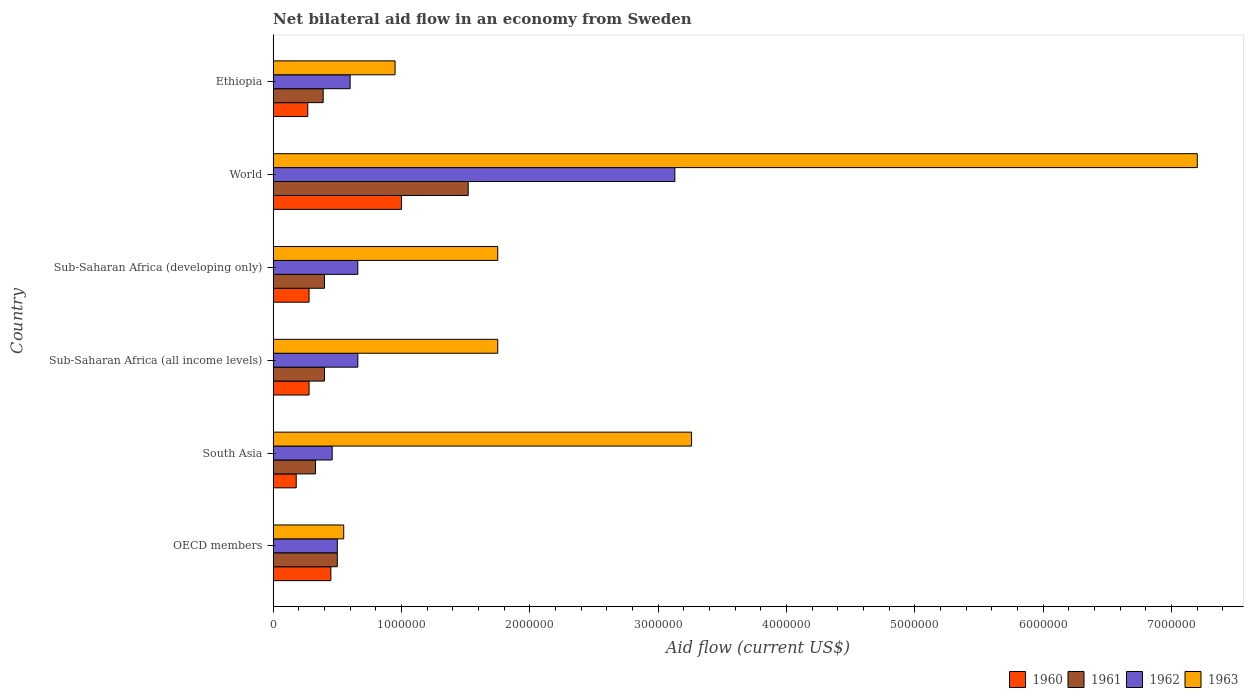What is the label of the 4th group of bars from the top?
Your answer should be very brief. Sub-Saharan Africa (all income levels). In how many cases, is the number of bars for a given country not equal to the number of legend labels?
Keep it short and to the point. 0. What is the net bilateral aid flow in 1961 in Sub-Saharan Africa (all income levels)?
Provide a short and direct response. 4.00e+05. Across all countries, what is the minimum net bilateral aid flow in 1963?
Your answer should be compact. 5.50e+05. What is the total net bilateral aid flow in 1960 in the graph?
Keep it short and to the point. 2.46e+06. What is the difference between the net bilateral aid flow in 1961 in Ethiopia and that in Sub-Saharan Africa (all income levels)?
Offer a very short reply. -10000. What is the difference between the net bilateral aid flow in 1961 and net bilateral aid flow in 1963 in Sub-Saharan Africa (developing only)?
Offer a very short reply. -1.35e+06. In how many countries, is the net bilateral aid flow in 1963 greater than 3400000 US$?
Your answer should be compact. 1. What is the ratio of the net bilateral aid flow in 1962 in Sub-Saharan Africa (developing only) to that in World?
Your answer should be compact. 0.21. Is the net bilateral aid flow in 1962 in Ethiopia less than that in Sub-Saharan Africa (developing only)?
Keep it short and to the point. Yes. Is the difference between the net bilateral aid flow in 1961 in Ethiopia and Sub-Saharan Africa (developing only) greater than the difference between the net bilateral aid flow in 1963 in Ethiopia and Sub-Saharan Africa (developing only)?
Your answer should be compact. Yes. What is the difference between the highest and the second highest net bilateral aid flow in 1961?
Provide a succinct answer. 1.02e+06. What is the difference between the highest and the lowest net bilateral aid flow in 1960?
Keep it short and to the point. 8.20e+05. What does the 2nd bar from the top in Sub-Saharan Africa (developing only) represents?
Provide a succinct answer. 1962. How many bars are there?
Your answer should be compact. 24. Are all the bars in the graph horizontal?
Offer a terse response. Yes. How many countries are there in the graph?
Offer a very short reply. 6. Does the graph contain grids?
Offer a terse response. No. Where does the legend appear in the graph?
Provide a succinct answer. Bottom right. How many legend labels are there?
Provide a succinct answer. 4. What is the title of the graph?
Provide a succinct answer. Net bilateral aid flow in an economy from Sweden. What is the Aid flow (current US$) of 1961 in OECD members?
Ensure brevity in your answer.  5.00e+05. What is the Aid flow (current US$) in 1961 in South Asia?
Provide a short and direct response. 3.30e+05. What is the Aid flow (current US$) of 1963 in South Asia?
Offer a very short reply. 3.26e+06. What is the Aid flow (current US$) in 1961 in Sub-Saharan Africa (all income levels)?
Ensure brevity in your answer.  4.00e+05. What is the Aid flow (current US$) of 1963 in Sub-Saharan Africa (all income levels)?
Your response must be concise. 1.75e+06. What is the Aid flow (current US$) of 1960 in Sub-Saharan Africa (developing only)?
Your answer should be compact. 2.80e+05. What is the Aid flow (current US$) in 1961 in Sub-Saharan Africa (developing only)?
Your answer should be very brief. 4.00e+05. What is the Aid flow (current US$) of 1963 in Sub-Saharan Africa (developing only)?
Your response must be concise. 1.75e+06. What is the Aid flow (current US$) in 1960 in World?
Offer a terse response. 1.00e+06. What is the Aid flow (current US$) in 1961 in World?
Provide a succinct answer. 1.52e+06. What is the Aid flow (current US$) in 1962 in World?
Your answer should be compact. 3.13e+06. What is the Aid flow (current US$) of 1963 in World?
Your response must be concise. 7.20e+06. What is the Aid flow (current US$) in 1962 in Ethiopia?
Your answer should be very brief. 6.00e+05. What is the Aid flow (current US$) in 1963 in Ethiopia?
Your answer should be compact. 9.50e+05. Across all countries, what is the maximum Aid flow (current US$) of 1961?
Keep it short and to the point. 1.52e+06. Across all countries, what is the maximum Aid flow (current US$) of 1962?
Provide a short and direct response. 3.13e+06. Across all countries, what is the maximum Aid flow (current US$) of 1963?
Ensure brevity in your answer.  7.20e+06. Across all countries, what is the minimum Aid flow (current US$) of 1960?
Provide a succinct answer. 1.80e+05. Across all countries, what is the minimum Aid flow (current US$) in 1961?
Keep it short and to the point. 3.30e+05. What is the total Aid flow (current US$) in 1960 in the graph?
Keep it short and to the point. 2.46e+06. What is the total Aid flow (current US$) of 1961 in the graph?
Keep it short and to the point. 3.54e+06. What is the total Aid flow (current US$) of 1962 in the graph?
Your answer should be compact. 6.01e+06. What is the total Aid flow (current US$) in 1963 in the graph?
Provide a short and direct response. 1.55e+07. What is the difference between the Aid flow (current US$) of 1961 in OECD members and that in South Asia?
Give a very brief answer. 1.70e+05. What is the difference between the Aid flow (current US$) in 1962 in OECD members and that in South Asia?
Make the answer very short. 4.00e+04. What is the difference between the Aid flow (current US$) in 1963 in OECD members and that in South Asia?
Provide a succinct answer. -2.71e+06. What is the difference between the Aid flow (current US$) in 1960 in OECD members and that in Sub-Saharan Africa (all income levels)?
Provide a succinct answer. 1.70e+05. What is the difference between the Aid flow (current US$) in 1961 in OECD members and that in Sub-Saharan Africa (all income levels)?
Your response must be concise. 1.00e+05. What is the difference between the Aid flow (current US$) in 1963 in OECD members and that in Sub-Saharan Africa (all income levels)?
Offer a terse response. -1.20e+06. What is the difference between the Aid flow (current US$) of 1961 in OECD members and that in Sub-Saharan Africa (developing only)?
Keep it short and to the point. 1.00e+05. What is the difference between the Aid flow (current US$) of 1963 in OECD members and that in Sub-Saharan Africa (developing only)?
Offer a very short reply. -1.20e+06. What is the difference between the Aid flow (current US$) in 1960 in OECD members and that in World?
Keep it short and to the point. -5.50e+05. What is the difference between the Aid flow (current US$) in 1961 in OECD members and that in World?
Make the answer very short. -1.02e+06. What is the difference between the Aid flow (current US$) in 1962 in OECD members and that in World?
Provide a succinct answer. -2.63e+06. What is the difference between the Aid flow (current US$) of 1963 in OECD members and that in World?
Your answer should be very brief. -6.65e+06. What is the difference between the Aid flow (current US$) in 1963 in OECD members and that in Ethiopia?
Offer a terse response. -4.00e+05. What is the difference between the Aid flow (current US$) in 1961 in South Asia and that in Sub-Saharan Africa (all income levels)?
Your answer should be compact. -7.00e+04. What is the difference between the Aid flow (current US$) in 1962 in South Asia and that in Sub-Saharan Africa (all income levels)?
Ensure brevity in your answer.  -2.00e+05. What is the difference between the Aid flow (current US$) in 1963 in South Asia and that in Sub-Saharan Africa (all income levels)?
Your response must be concise. 1.51e+06. What is the difference between the Aid flow (current US$) in 1962 in South Asia and that in Sub-Saharan Africa (developing only)?
Make the answer very short. -2.00e+05. What is the difference between the Aid flow (current US$) in 1963 in South Asia and that in Sub-Saharan Africa (developing only)?
Provide a succinct answer. 1.51e+06. What is the difference between the Aid flow (current US$) of 1960 in South Asia and that in World?
Offer a very short reply. -8.20e+05. What is the difference between the Aid flow (current US$) in 1961 in South Asia and that in World?
Offer a terse response. -1.19e+06. What is the difference between the Aid flow (current US$) in 1962 in South Asia and that in World?
Your answer should be very brief. -2.67e+06. What is the difference between the Aid flow (current US$) of 1963 in South Asia and that in World?
Your response must be concise. -3.94e+06. What is the difference between the Aid flow (current US$) in 1960 in South Asia and that in Ethiopia?
Your answer should be compact. -9.00e+04. What is the difference between the Aid flow (current US$) in 1961 in South Asia and that in Ethiopia?
Offer a very short reply. -6.00e+04. What is the difference between the Aid flow (current US$) in 1963 in South Asia and that in Ethiopia?
Make the answer very short. 2.31e+06. What is the difference between the Aid flow (current US$) of 1960 in Sub-Saharan Africa (all income levels) and that in Sub-Saharan Africa (developing only)?
Your answer should be compact. 0. What is the difference between the Aid flow (current US$) in 1962 in Sub-Saharan Africa (all income levels) and that in Sub-Saharan Africa (developing only)?
Your answer should be compact. 0. What is the difference between the Aid flow (current US$) of 1963 in Sub-Saharan Africa (all income levels) and that in Sub-Saharan Africa (developing only)?
Ensure brevity in your answer.  0. What is the difference between the Aid flow (current US$) in 1960 in Sub-Saharan Africa (all income levels) and that in World?
Offer a very short reply. -7.20e+05. What is the difference between the Aid flow (current US$) of 1961 in Sub-Saharan Africa (all income levels) and that in World?
Your answer should be very brief. -1.12e+06. What is the difference between the Aid flow (current US$) in 1962 in Sub-Saharan Africa (all income levels) and that in World?
Provide a short and direct response. -2.47e+06. What is the difference between the Aid flow (current US$) in 1963 in Sub-Saharan Africa (all income levels) and that in World?
Give a very brief answer. -5.45e+06. What is the difference between the Aid flow (current US$) of 1962 in Sub-Saharan Africa (all income levels) and that in Ethiopia?
Make the answer very short. 6.00e+04. What is the difference between the Aid flow (current US$) of 1960 in Sub-Saharan Africa (developing only) and that in World?
Provide a short and direct response. -7.20e+05. What is the difference between the Aid flow (current US$) in 1961 in Sub-Saharan Africa (developing only) and that in World?
Give a very brief answer. -1.12e+06. What is the difference between the Aid flow (current US$) of 1962 in Sub-Saharan Africa (developing only) and that in World?
Offer a terse response. -2.47e+06. What is the difference between the Aid flow (current US$) in 1963 in Sub-Saharan Africa (developing only) and that in World?
Provide a succinct answer. -5.45e+06. What is the difference between the Aid flow (current US$) in 1963 in Sub-Saharan Africa (developing only) and that in Ethiopia?
Ensure brevity in your answer.  8.00e+05. What is the difference between the Aid flow (current US$) in 1960 in World and that in Ethiopia?
Make the answer very short. 7.30e+05. What is the difference between the Aid flow (current US$) in 1961 in World and that in Ethiopia?
Your answer should be compact. 1.13e+06. What is the difference between the Aid flow (current US$) of 1962 in World and that in Ethiopia?
Offer a very short reply. 2.53e+06. What is the difference between the Aid flow (current US$) of 1963 in World and that in Ethiopia?
Offer a very short reply. 6.25e+06. What is the difference between the Aid flow (current US$) in 1960 in OECD members and the Aid flow (current US$) in 1962 in South Asia?
Provide a short and direct response. -10000. What is the difference between the Aid flow (current US$) in 1960 in OECD members and the Aid flow (current US$) in 1963 in South Asia?
Your answer should be very brief. -2.81e+06. What is the difference between the Aid flow (current US$) in 1961 in OECD members and the Aid flow (current US$) in 1962 in South Asia?
Ensure brevity in your answer.  4.00e+04. What is the difference between the Aid flow (current US$) of 1961 in OECD members and the Aid flow (current US$) of 1963 in South Asia?
Provide a succinct answer. -2.76e+06. What is the difference between the Aid flow (current US$) of 1962 in OECD members and the Aid flow (current US$) of 1963 in South Asia?
Provide a short and direct response. -2.76e+06. What is the difference between the Aid flow (current US$) of 1960 in OECD members and the Aid flow (current US$) of 1961 in Sub-Saharan Africa (all income levels)?
Your answer should be very brief. 5.00e+04. What is the difference between the Aid flow (current US$) in 1960 in OECD members and the Aid flow (current US$) in 1962 in Sub-Saharan Africa (all income levels)?
Your answer should be very brief. -2.10e+05. What is the difference between the Aid flow (current US$) in 1960 in OECD members and the Aid flow (current US$) in 1963 in Sub-Saharan Africa (all income levels)?
Make the answer very short. -1.30e+06. What is the difference between the Aid flow (current US$) of 1961 in OECD members and the Aid flow (current US$) of 1962 in Sub-Saharan Africa (all income levels)?
Offer a very short reply. -1.60e+05. What is the difference between the Aid flow (current US$) in 1961 in OECD members and the Aid flow (current US$) in 1963 in Sub-Saharan Africa (all income levels)?
Your response must be concise. -1.25e+06. What is the difference between the Aid flow (current US$) of 1962 in OECD members and the Aid flow (current US$) of 1963 in Sub-Saharan Africa (all income levels)?
Ensure brevity in your answer.  -1.25e+06. What is the difference between the Aid flow (current US$) of 1960 in OECD members and the Aid flow (current US$) of 1962 in Sub-Saharan Africa (developing only)?
Keep it short and to the point. -2.10e+05. What is the difference between the Aid flow (current US$) in 1960 in OECD members and the Aid flow (current US$) in 1963 in Sub-Saharan Africa (developing only)?
Make the answer very short. -1.30e+06. What is the difference between the Aid flow (current US$) of 1961 in OECD members and the Aid flow (current US$) of 1962 in Sub-Saharan Africa (developing only)?
Make the answer very short. -1.60e+05. What is the difference between the Aid flow (current US$) in 1961 in OECD members and the Aid flow (current US$) in 1963 in Sub-Saharan Africa (developing only)?
Provide a succinct answer. -1.25e+06. What is the difference between the Aid flow (current US$) of 1962 in OECD members and the Aid flow (current US$) of 1963 in Sub-Saharan Africa (developing only)?
Ensure brevity in your answer.  -1.25e+06. What is the difference between the Aid flow (current US$) of 1960 in OECD members and the Aid flow (current US$) of 1961 in World?
Your response must be concise. -1.07e+06. What is the difference between the Aid flow (current US$) in 1960 in OECD members and the Aid flow (current US$) in 1962 in World?
Make the answer very short. -2.68e+06. What is the difference between the Aid flow (current US$) in 1960 in OECD members and the Aid flow (current US$) in 1963 in World?
Make the answer very short. -6.75e+06. What is the difference between the Aid flow (current US$) of 1961 in OECD members and the Aid flow (current US$) of 1962 in World?
Make the answer very short. -2.63e+06. What is the difference between the Aid flow (current US$) in 1961 in OECD members and the Aid flow (current US$) in 1963 in World?
Your answer should be compact. -6.70e+06. What is the difference between the Aid flow (current US$) of 1962 in OECD members and the Aid flow (current US$) of 1963 in World?
Make the answer very short. -6.70e+06. What is the difference between the Aid flow (current US$) of 1960 in OECD members and the Aid flow (current US$) of 1962 in Ethiopia?
Your answer should be very brief. -1.50e+05. What is the difference between the Aid flow (current US$) of 1960 in OECD members and the Aid flow (current US$) of 1963 in Ethiopia?
Ensure brevity in your answer.  -5.00e+05. What is the difference between the Aid flow (current US$) of 1961 in OECD members and the Aid flow (current US$) of 1963 in Ethiopia?
Offer a terse response. -4.50e+05. What is the difference between the Aid flow (current US$) of 1962 in OECD members and the Aid flow (current US$) of 1963 in Ethiopia?
Keep it short and to the point. -4.50e+05. What is the difference between the Aid flow (current US$) in 1960 in South Asia and the Aid flow (current US$) in 1961 in Sub-Saharan Africa (all income levels)?
Make the answer very short. -2.20e+05. What is the difference between the Aid flow (current US$) in 1960 in South Asia and the Aid flow (current US$) in 1962 in Sub-Saharan Africa (all income levels)?
Offer a terse response. -4.80e+05. What is the difference between the Aid flow (current US$) in 1960 in South Asia and the Aid flow (current US$) in 1963 in Sub-Saharan Africa (all income levels)?
Offer a terse response. -1.57e+06. What is the difference between the Aid flow (current US$) of 1961 in South Asia and the Aid flow (current US$) of 1962 in Sub-Saharan Africa (all income levels)?
Your answer should be very brief. -3.30e+05. What is the difference between the Aid flow (current US$) of 1961 in South Asia and the Aid flow (current US$) of 1963 in Sub-Saharan Africa (all income levels)?
Ensure brevity in your answer.  -1.42e+06. What is the difference between the Aid flow (current US$) of 1962 in South Asia and the Aid flow (current US$) of 1963 in Sub-Saharan Africa (all income levels)?
Offer a very short reply. -1.29e+06. What is the difference between the Aid flow (current US$) in 1960 in South Asia and the Aid flow (current US$) in 1961 in Sub-Saharan Africa (developing only)?
Provide a succinct answer. -2.20e+05. What is the difference between the Aid flow (current US$) in 1960 in South Asia and the Aid flow (current US$) in 1962 in Sub-Saharan Africa (developing only)?
Your response must be concise. -4.80e+05. What is the difference between the Aid flow (current US$) of 1960 in South Asia and the Aid flow (current US$) of 1963 in Sub-Saharan Africa (developing only)?
Provide a succinct answer. -1.57e+06. What is the difference between the Aid flow (current US$) of 1961 in South Asia and the Aid flow (current US$) of 1962 in Sub-Saharan Africa (developing only)?
Offer a very short reply. -3.30e+05. What is the difference between the Aid flow (current US$) in 1961 in South Asia and the Aid flow (current US$) in 1963 in Sub-Saharan Africa (developing only)?
Your answer should be compact. -1.42e+06. What is the difference between the Aid flow (current US$) of 1962 in South Asia and the Aid flow (current US$) of 1963 in Sub-Saharan Africa (developing only)?
Offer a very short reply. -1.29e+06. What is the difference between the Aid flow (current US$) of 1960 in South Asia and the Aid flow (current US$) of 1961 in World?
Your answer should be compact. -1.34e+06. What is the difference between the Aid flow (current US$) of 1960 in South Asia and the Aid flow (current US$) of 1962 in World?
Give a very brief answer. -2.95e+06. What is the difference between the Aid flow (current US$) in 1960 in South Asia and the Aid flow (current US$) in 1963 in World?
Your answer should be very brief. -7.02e+06. What is the difference between the Aid flow (current US$) in 1961 in South Asia and the Aid flow (current US$) in 1962 in World?
Provide a short and direct response. -2.80e+06. What is the difference between the Aid flow (current US$) of 1961 in South Asia and the Aid flow (current US$) of 1963 in World?
Your answer should be very brief. -6.87e+06. What is the difference between the Aid flow (current US$) in 1962 in South Asia and the Aid flow (current US$) in 1963 in World?
Your answer should be very brief. -6.74e+06. What is the difference between the Aid flow (current US$) of 1960 in South Asia and the Aid flow (current US$) of 1961 in Ethiopia?
Give a very brief answer. -2.10e+05. What is the difference between the Aid flow (current US$) in 1960 in South Asia and the Aid flow (current US$) in 1962 in Ethiopia?
Make the answer very short. -4.20e+05. What is the difference between the Aid flow (current US$) in 1960 in South Asia and the Aid flow (current US$) in 1963 in Ethiopia?
Your answer should be very brief. -7.70e+05. What is the difference between the Aid flow (current US$) in 1961 in South Asia and the Aid flow (current US$) in 1963 in Ethiopia?
Your response must be concise. -6.20e+05. What is the difference between the Aid flow (current US$) of 1962 in South Asia and the Aid flow (current US$) of 1963 in Ethiopia?
Ensure brevity in your answer.  -4.90e+05. What is the difference between the Aid flow (current US$) in 1960 in Sub-Saharan Africa (all income levels) and the Aid flow (current US$) in 1961 in Sub-Saharan Africa (developing only)?
Your response must be concise. -1.20e+05. What is the difference between the Aid flow (current US$) in 1960 in Sub-Saharan Africa (all income levels) and the Aid flow (current US$) in 1962 in Sub-Saharan Africa (developing only)?
Give a very brief answer. -3.80e+05. What is the difference between the Aid flow (current US$) in 1960 in Sub-Saharan Africa (all income levels) and the Aid flow (current US$) in 1963 in Sub-Saharan Africa (developing only)?
Provide a short and direct response. -1.47e+06. What is the difference between the Aid flow (current US$) in 1961 in Sub-Saharan Africa (all income levels) and the Aid flow (current US$) in 1962 in Sub-Saharan Africa (developing only)?
Provide a short and direct response. -2.60e+05. What is the difference between the Aid flow (current US$) in 1961 in Sub-Saharan Africa (all income levels) and the Aid flow (current US$) in 1963 in Sub-Saharan Africa (developing only)?
Ensure brevity in your answer.  -1.35e+06. What is the difference between the Aid flow (current US$) in 1962 in Sub-Saharan Africa (all income levels) and the Aid flow (current US$) in 1963 in Sub-Saharan Africa (developing only)?
Keep it short and to the point. -1.09e+06. What is the difference between the Aid flow (current US$) in 1960 in Sub-Saharan Africa (all income levels) and the Aid flow (current US$) in 1961 in World?
Your response must be concise. -1.24e+06. What is the difference between the Aid flow (current US$) in 1960 in Sub-Saharan Africa (all income levels) and the Aid flow (current US$) in 1962 in World?
Ensure brevity in your answer.  -2.85e+06. What is the difference between the Aid flow (current US$) in 1960 in Sub-Saharan Africa (all income levels) and the Aid flow (current US$) in 1963 in World?
Your response must be concise. -6.92e+06. What is the difference between the Aid flow (current US$) of 1961 in Sub-Saharan Africa (all income levels) and the Aid flow (current US$) of 1962 in World?
Provide a succinct answer. -2.73e+06. What is the difference between the Aid flow (current US$) in 1961 in Sub-Saharan Africa (all income levels) and the Aid flow (current US$) in 1963 in World?
Your answer should be compact. -6.80e+06. What is the difference between the Aid flow (current US$) of 1962 in Sub-Saharan Africa (all income levels) and the Aid flow (current US$) of 1963 in World?
Give a very brief answer. -6.54e+06. What is the difference between the Aid flow (current US$) in 1960 in Sub-Saharan Africa (all income levels) and the Aid flow (current US$) in 1962 in Ethiopia?
Offer a very short reply. -3.20e+05. What is the difference between the Aid flow (current US$) in 1960 in Sub-Saharan Africa (all income levels) and the Aid flow (current US$) in 1963 in Ethiopia?
Your response must be concise. -6.70e+05. What is the difference between the Aid flow (current US$) in 1961 in Sub-Saharan Africa (all income levels) and the Aid flow (current US$) in 1962 in Ethiopia?
Your answer should be very brief. -2.00e+05. What is the difference between the Aid flow (current US$) of 1961 in Sub-Saharan Africa (all income levels) and the Aid flow (current US$) of 1963 in Ethiopia?
Keep it short and to the point. -5.50e+05. What is the difference between the Aid flow (current US$) of 1962 in Sub-Saharan Africa (all income levels) and the Aid flow (current US$) of 1963 in Ethiopia?
Give a very brief answer. -2.90e+05. What is the difference between the Aid flow (current US$) in 1960 in Sub-Saharan Africa (developing only) and the Aid flow (current US$) in 1961 in World?
Keep it short and to the point. -1.24e+06. What is the difference between the Aid flow (current US$) of 1960 in Sub-Saharan Africa (developing only) and the Aid flow (current US$) of 1962 in World?
Keep it short and to the point. -2.85e+06. What is the difference between the Aid flow (current US$) of 1960 in Sub-Saharan Africa (developing only) and the Aid flow (current US$) of 1963 in World?
Your answer should be very brief. -6.92e+06. What is the difference between the Aid flow (current US$) in 1961 in Sub-Saharan Africa (developing only) and the Aid flow (current US$) in 1962 in World?
Make the answer very short. -2.73e+06. What is the difference between the Aid flow (current US$) of 1961 in Sub-Saharan Africa (developing only) and the Aid flow (current US$) of 1963 in World?
Provide a succinct answer. -6.80e+06. What is the difference between the Aid flow (current US$) in 1962 in Sub-Saharan Africa (developing only) and the Aid flow (current US$) in 1963 in World?
Provide a succinct answer. -6.54e+06. What is the difference between the Aid flow (current US$) of 1960 in Sub-Saharan Africa (developing only) and the Aid flow (current US$) of 1962 in Ethiopia?
Provide a short and direct response. -3.20e+05. What is the difference between the Aid flow (current US$) of 1960 in Sub-Saharan Africa (developing only) and the Aid flow (current US$) of 1963 in Ethiopia?
Provide a short and direct response. -6.70e+05. What is the difference between the Aid flow (current US$) of 1961 in Sub-Saharan Africa (developing only) and the Aid flow (current US$) of 1963 in Ethiopia?
Keep it short and to the point. -5.50e+05. What is the difference between the Aid flow (current US$) of 1962 in Sub-Saharan Africa (developing only) and the Aid flow (current US$) of 1963 in Ethiopia?
Offer a very short reply. -2.90e+05. What is the difference between the Aid flow (current US$) of 1960 in World and the Aid flow (current US$) of 1962 in Ethiopia?
Give a very brief answer. 4.00e+05. What is the difference between the Aid flow (current US$) in 1961 in World and the Aid flow (current US$) in 1962 in Ethiopia?
Offer a very short reply. 9.20e+05. What is the difference between the Aid flow (current US$) in 1961 in World and the Aid flow (current US$) in 1963 in Ethiopia?
Offer a very short reply. 5.70e+05. What is the difference between the Aid flow (current US$) in 1962 in World and the Aid flow (current US$) in 1963 in Ethiopia?
Your answer should be very brief. 2.18e+06. What is the average Aid flow (current US$) in 1961 per country?
Ensure brevity in your answer.  5.90e+05. What is the average Aid flow (current US$) of 1962 per country?
Keep it short and to the point. 1.00e+06. What is the average Aid flow (current US$) of 1963 per country?
Give a very brief answer. 2.58e+06. What is the difference between the Aid flow (current US$) in 1960 and Aid flow (current US$) in 1961 in OECD members?
Your answer should be compact. -5.00e+04. What is the difference between the Aid flow (current US$) of 1960 and Aid flow (current US$) of 1963 in OECD members?
Offer a very short reply. -1.00e+05. What is the difference between the Aid flow (current US$) of 1961 and Aid flow (current US$) of 1962 in OECD members?
Give a very brief answer. 0. What is the difference between the Aid flow (current US$) in 1961 and Aid flow (current US$) in 1963 in OECD members?
Keep it short and to the point. -5.00e+04. What is the difference between the Aid flow (current US$) in 1962 and Aid flow (current US$) in 1963 in OECD members?
Your answer should be very brief. -5.00e+04. What is the difference between the Aid flow (current US$) in 1960 and Aid flow (current US$) in 1962 in South Asia?
Offer a very short reply. -2.80e+05. What is the difference between the Aid flow (current US$) of 1960 and Aid flow (current US$) of 1963 in South Asia?
Your answer should be very brief. -3.08e+06. What is the difference between the Aid flow (current US$) of 1961 and Aid flow (current US$) of 1962 in South Asia?
Offer a terse response. -1.30e+05. What is the difference between the Aid flow (current US$) of 1961 and Aid flow (current US$) of 1963 in South Asia?
Your answer should be very brief. -2.93e+06. What is the difference between the Aid flow (current US$) in 1962 and Aid flow (current US$) in 1963 in South Asia?
Keep it short and to the point. -2.80e+06. What is the difference between the Aid flow (current US$) in 1960 and Aid flow (current US$) in 1962 in Sub-Saharan Africa (all income levels)?
Your response must be concise. -3.80e+05. What is the difference between the Aid flow (current US$) of 1960 and Aid flow (current US$) of 1963 in Sub-Saharan Africa (all income levels)?
Offer a very short reply. -1.47e+06. What is the difference between the Aid flow (current US$) of 1961 and Aid flow (current US$) of 1962 in Sub-Saharan Africa (all income levels)?
Give a very brief answer. -2.60e+05. What is the difference between the Aid flow (current US$) of 1961 and Aid flow (current US$) of 1963 in Sub-Saharan Africa (all income levels)?
Keep it short and to the point. -1.35e+06. What is the difference between the Aid flow (current US$) in 1962 and Aid flow (current US$) in 1963 in Sub-Saharan Africa (all income levels)?
Provide a short and direct response. -1.09e+06. What is the difference between the Aid flow (current US$) in 1960 and Aid flow (current US$) in 1961 in Sub-Saharan Africa (developing only)?
Your answer should be compact. -1.20e+05. What is the difference between the Aid flow (current US$) in 1960 and Aid flow (current US$) in 1962 in Sub-Saharan Africa (developing only)?
Your answer should be very brief. -3.80e+05. What is the difference between the Aid flow (current US$) of 1960 and Aid flow (current US$) of 1963 in Sub-Saharan Africa (developing only)?
Make the answer very short. -1.47e+06. What is the difference between the Aid flow (current US$) in 1961 and Aid flow (current US$) in 1963 in Sub-Saharan Africa (developing only)?
Keep it short and to the point. -1.35e+06. What is the difference between the Aid flow (current US$) of 1962 and Aid flow (current US$) of 1963 in Sub-Saharan Africa (developing only)?
Provide a succinct answer. -1.09e+06. What is the difference between the Aid flow (current US$) of 1960 and Aid flow (current US$) of 1961 in World?
Provide a succinct answer. -5.20e+05. What is the difference between the Aid flow (current US$) in 1960 and Aid flow (current US$) in 1962 in World?
Provide a succinct answer. -2.13e+06. What is the difference between the Aid flow (current US$) of 1960 and Aid flow (current US$) of 1963 in World?
Your answer should be compact. -6.20e+06. What is the difference between the Aid flow (current US$) in 1961 and Aid flow (current US$) in 1962 in World?
Your response must be concise. -1.61e+06. What is the difference between the Aid flow (current US$) of 1961 and Aid flow (current US$) of 1963 in World?
Your answer should be compact. -5.68e+06. What is the difference between the Aid flow (current US$) of 1962 and Aid flow (current US$) of 1963 in World?
Offer a very short reply. -4.07e+06. What is the difference between the Aid flow (current US$) in 1960 and Aid flow (current US$) in 1962 in Ethiopia?
Offer a terse response. -3.30e+05. What is the difference between the Aid flow (current US$) of 1960 and Aid flow (current US$) of 1963 in Ethiopia?
Provide a succinct answer. -6.80e+05. What is the difference between the Aid flow (current US$) in 1961 and Aid flow (current US$) in 1962 in Ethiopia?
Your answer should be very brief. -2.10e+05. What is the difference between the Aid flow (current US$) in 1961 and Aid flow (current US$) in 1963 in Ethiopia?
Ensure brevity in your answer.  -5.60e+05. What is the difference between the Aid flow (current US$) of 1962 and Aid flow (current US$) of 1963 in Ethiopia?
Offer a very short reply. -3.50e+05. What is the ratio of the Aid flow (current US$) in 1960 in OECD members to that in South Asia?
Make the answer very short. 2.5. What is the ratio of the Aid flow (current US$) of 1961 in OECD members to that in South Asia?
Provide a short and direct response. 1.52. What is the ratio of the Aid flow (current US$) of 1962 in OECD members to that in South Asia?
Provide a short and direct response. 1.09. What is the ratio of the Aid flow (current US$) in 1963 in OECD members to that in South Asia?
Provide a short and direct response. 0.17. What is the ratio of the Aid flow (current US$) of 1960 in OECD members to that in Sub-Saharan Africa (all income levels)?
Your response must be concise. 1.61. What is the ratio of the Aid flow (current US$) in 1961 in OECD members to that in Sub-Saharan Africa (all income levels)?
Ensure brevity in your answer.  1.25. What is the ratio of the Aid flow (current US$) of 1962 in OECD members to that in Sub-Saharan Africa (all income levels)?
Offer a very short reply. 0.76. What is the ratio of the Aid flow (current US$) in 1963 in OECD members to that in Sub-Saharan Africa (all income levels)?
Your answer should be very brief. 0.31. What is the ratio of the Aid flow (current US$) in 1960 in OECD members to that in Sub-Saharan Africa (developing only)?
Your answer should be compact. 1.61. What is the ratio of the Aid flow (current US$) of 1962 in OECD members to that in Sub-Saharan Africa (developing only)?
Provide a succinct answer. 0.76. What is the ratio of the Aid flow (current US$) in 1963 in OECD members to that in Sub-Saharan Africa (developing only)?
Provide a succinct answer. 0.31. What is the ratio of the Aid flow (current US$) of 1960 in OECD members to that in World?
Keep it short and to the point. 0.45. What is the ratio of the Aid flow (current US$) of 1961 in OECD members to that in World?
Offer a terse response. 0.33. What is the ratio of the Aid flow (current US$) of 1962 in OECD members to that in World?
Your answer should be very brief. 0.16. What is the ratio of the Aid flow (current US$) of 1963 in OECD members to that in World?
Offer a very short reply. 0.08. What is the ratio of the Aid flow (current US$) of 1960 in OECD members to that in Ethiopia?
Provide a succinct answer. 1.67. What is the ratio of the Aid flow (current US$) of 1961 in OECD members to that in Ethiopia?
Provide a short and direct response. 1.28. What is the ratio of the Aid flow (current US$) of 1962 in OECD members to that in Ethiopia?
Provide a succinct answer. 0.83. What is the ratio of the Aid flow (current US$) of 1963 in OECD members to that in Ethiopia?
Your response must be concise. 0.58. What is the ratio of the Aid flow (current US$) of 1960 in South Asia to that in Sub-Saharan Africa (all income levels)?
Your response must be concise. 0.64. What is the ratio of the Aid flow (current US$) of 1961 in South Asia to that in Sub-Saharan Africa (all income levels)?
Offer a terse response. 0.82. What is the ratio of the Aid flow (current US$) in 1962 in South Asia to that in Sub-Saharan Africa (all income levels)?
Your response must be concise. 0.7. What is the ratio of the Aid flow (current US$) in 1963 in South Asia to that in Sub-Saharan Africa (all income levels)?
Offer a very short reply. 1.86. What is the ratio of the Aid flow (current US$) in 1960 in South Asia to that in Sub-Saharan Africa (developing only)?
Offer a terse response. 0.64. What is the ratio of the Aid flow (current US$) of 1961 in South Asia to that in Sub-Saharan Africa (developing only)?
Provide a succinct answer. 0.82. What is the ratio of the Aid flow (current US$) of 1962 in South Asia to that in Sub-Saharan Africa (developing only)?
Ensure brevity in your answer.  0.7. What is the ratio of the Aid flow (current US$) in 1963 in South Asia to that in Sub-Saharan Africa (developing only)?
Keep it short and to the point. 1.86. What is the ratio of the Aid flow (current US$) in 1960 in South Asia to that in World?
Make the answer very short. 0.18. What is the ratio of the Aid flow (current US$) of 1961 in South Asia to that in World?
Ensure brevity in your answer.  0.22. What is the ratio of the Aid flow (current US$) in 1962 in South Asia to that in World?
Make the answer very short. 0.15. What is the ratio of the Aid flow (current US$) in 1963 in South Asia to that in World?
Give a very brief answer. 0.45. What is the ratio of the Aid flow (current US$) in 1960 in South Asia to that in Ethiopia?
Offer a very short reply. 0.67. What is the ratio of the Aid flow (current US$) of 1961 in South Asia to that in Ethiopia?
Give a very brief answer. 0.85. What is the ratio of the Aid flow (current US$) in 1962 in South Asia to that in Ethiopia?
Offer a terse response. 0.77. What is the ratio of the Aid flow (current US$) in 1963 in South Asia to that in Ethiopia?
Your answer should be very brief. 3.43. What is the ratio of the Aid flow (current US$) in 1962 in Sub-Saharan Africa (all income levels) to that in Sub-Saharan Africa (developing only)?
Give a very brief answer. 1. What is the ratio of the Aid flow (current US$) of 1963 in Sub-Saharan Africa (all income levels) to that in Sub-Saharan Africa (developing only)?
Give a very brief answer. 1. What is the ratio of the Aid flow (current US$) in 1960 in Sub-Saharan Africa (all income levels) to that in World?
Provide a short and direct response. 0.28. What is the ratio of the Aid flow (current US$) in 1961 in Sub-Saharan Africa (all income levels) to that in World?
Your answer should be compact. 0.26. What is the ratio of the Aid flow (current US$) in 1962 in Sub-Saharan Africa (all income levels) to that in World?
Provide a short and direct response. 0.21. What is the ratio of the Aid flow (current US$) in 1963 in Sub-Saharan Africa (all income levels) to that in World?
Provide a succinct answer. 0.24. What is the ratio of the Aid flow (current US$) of 1961 in Sub-Saharan Africa (all income levels) to that in Ethiopia?
Give a very brief answer. 1.03. What is the ratio of the Aid flow (current US$) of 1963 in Sub-Saharan Africa (all income levels) to that in Ethiopia?
Your answer should be very brief. 1.84. What is the ratio of the Aid flow (current US$) of 1960 in Sub-Saharan Africa (developing only) to that in World?
Provide a short and direct response. 0.28. What is the ratio of the Aid flow (current US$) of 1961 in Sub-Saharan Africa (developing only) to that in World?
Your answer should be compact. 0.26. What is the ratio of the Aid flow (current US$) of 1962 in Sub-Saharan Africa (developing only) to that in World?
Ensure brevity in your answer.  0.21. What is the ratio of the Aid flow (current US$) in 1963 in Sub-Saharan Africa (developing only) to that in World?
Offer a very short reply. 0.24. What is the ratio of the Aid flow (current US$) of 1960 in Sub-Saharan Africa (developing only) to that in Ethiopia?
Ensure brevity in your answer.  1.04. What is the ratio of the Aid flow (current US$) in 1961 in Sub-Saharan Africa (developing only) to that in Ethiopia?
Your answer should be very brief. 1.03. What is the ratio of the Aid flow (current US$) of 1962 in Sub-Saharan Africa (developing only) to that in Ethiopia?
Ensure brevity in your answer.  1.1. What is the ratio of the Aid flow (current US$) in 1963 in Sub-Saharan Africa (developing only) to that in Ethiopia?
Your answer should be compact. 1.84. What is the ratio of the Aid flow (current US$) in 1960 in World to that in Ethiopia?
Ensure brevity in your answer.  3.7. What is the ratio of the Aid flow (current US$) of 1961 in World to that in Ethiopia?
Your answer should be very brief. 3.9. What is the ratio of the Aid flow (current US$) in 1962 in World to that in Ethiopia?
Provide a succinct answer. 5.22. What is the ratio of the Aid flow (current US$) of 1963 in World to that in Ethiopia?
Offer a very short reply. 7.58. What is the difference between the highest and the second highest Aid flow (current US$) of 1961?
Your answer should be compact. 1.02e+06. What is the difference between the highest and the second highest Aid flow (current US$) of 1962?
Keep it short and to the point. 2.47e+06. What is the difference between the highest and the second highest Aid flow (current US$) of 1963?
Give a very brief answer. 3.94e+06. What is the difference between the highest and the lowest Aid flow (current US$) in 1960?
Your answer should be very brief. 8.20e+05. What is the difference between the highest and the lowest Aid flow (current US$) in 1961?
Your answer should be very brief. 1.19e+06. What is the difference between the highest and the lowest Aid flow (current US$) in 1962?
Offer a very short reply. 2.67e+06. What is the difference between the highest and the lowest Aid flow (current US$) in 1963?
Make the answer very short. 6.65e+06. 